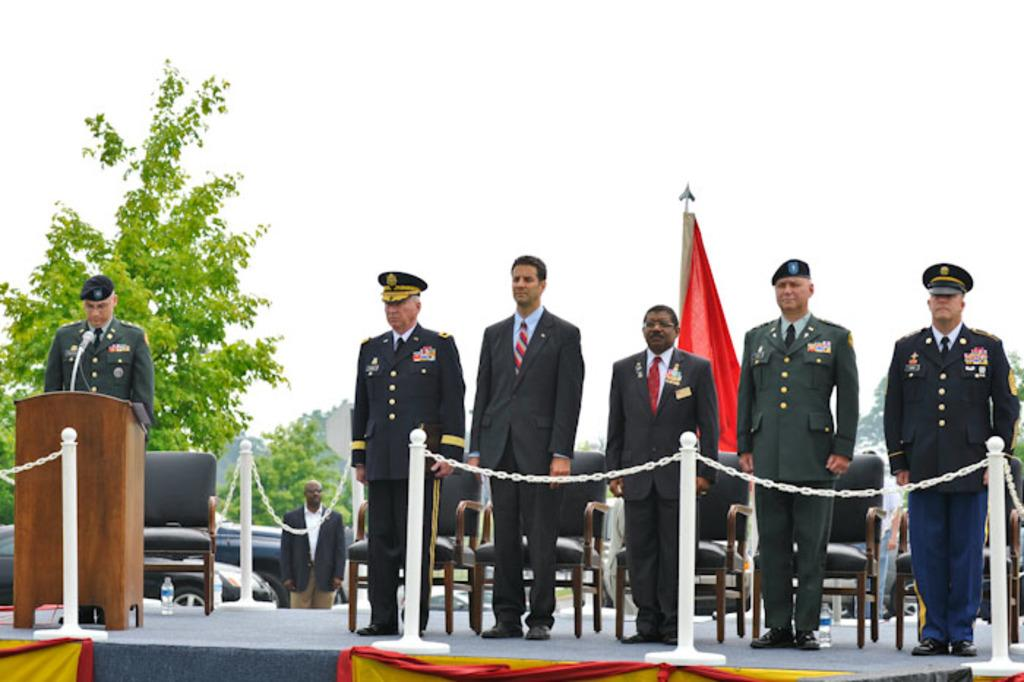What is happening on the stage in the image? There are people on the stage in the image. What object is present on the stage for the people to use? There is a podium in the image. What item can be seen near the people on the stage? There is a bottle in the image. What device is present for the people to speak into? There is a microphone (mic) in the image. What type of seating is available in the image? There are chairs in the image. What can be seen in the background of the image? There are vehicles, trees, and the sky visible in the background of the image. What type of mint is being used as an ornament on the microphone in the image? There is no mint or ornament present on the microphone in the image. What color is the sweater worn by the person on the stage in the image? There is no sweater visible on any person in the image. 